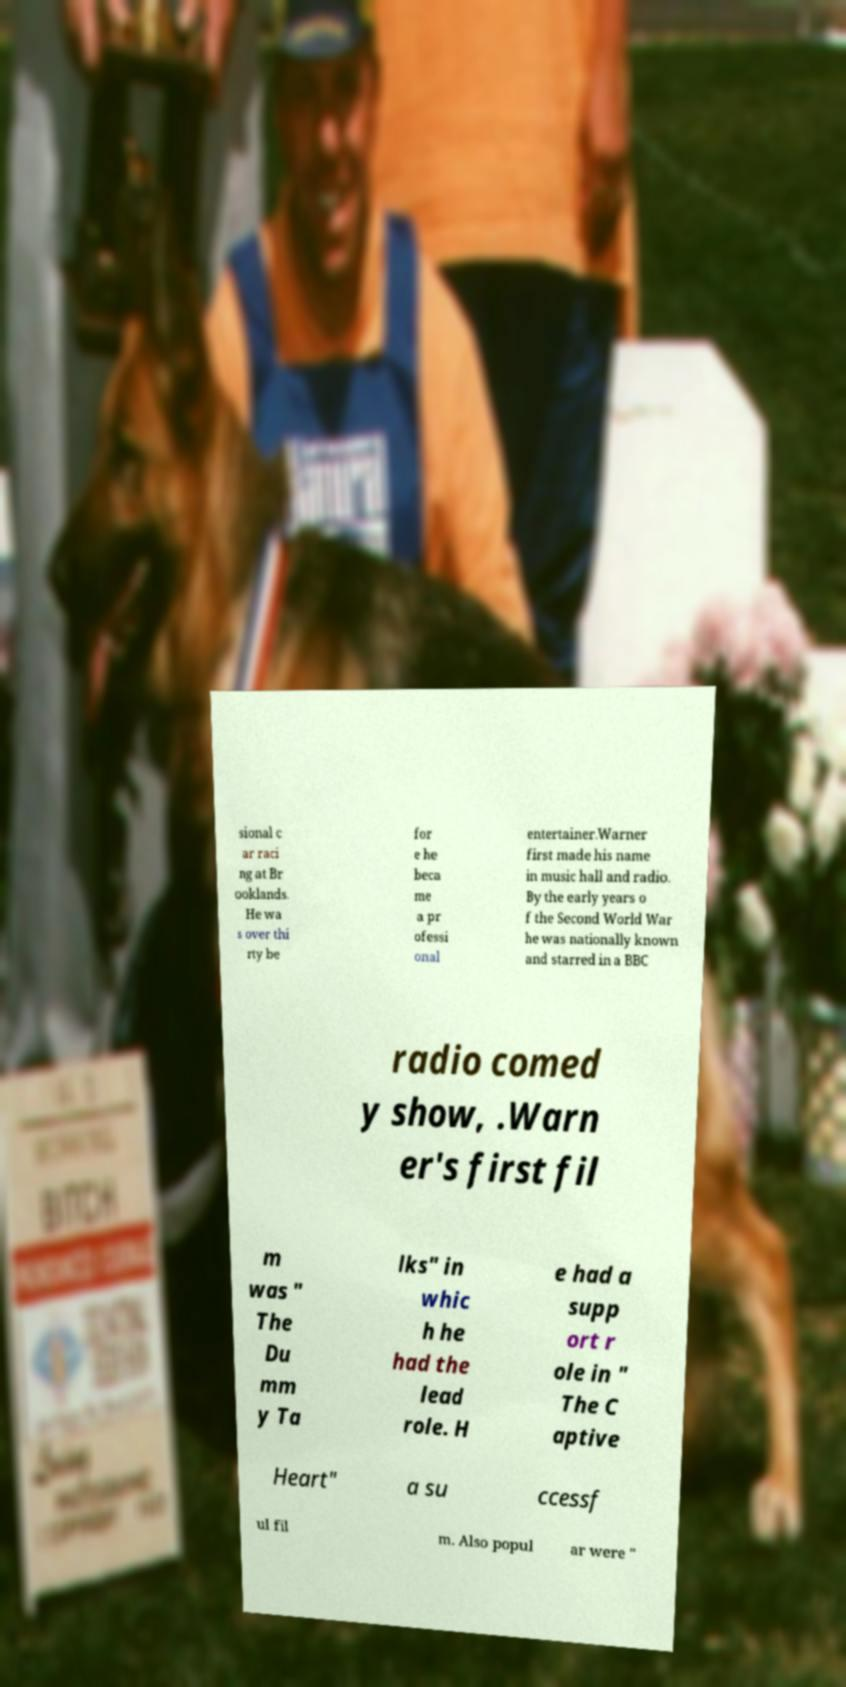Could you extract and type out the text from this image? sional c ar raci ng at Br ooklands. He wa s over thi rty be for e he beca me a pr ofessi onal entertainer.Warner first made his name in music hall and radio. By the early years o f the Second World War he was nationally known and starred in a BBC radio comed y show, .Warn er's first fil m was " The Du mm y Ta lks" in whic h he had the lead role. H e had a supp ort r ole in " The C aptive Heart" a su ccessf ul fil m. Also popul ar were " 